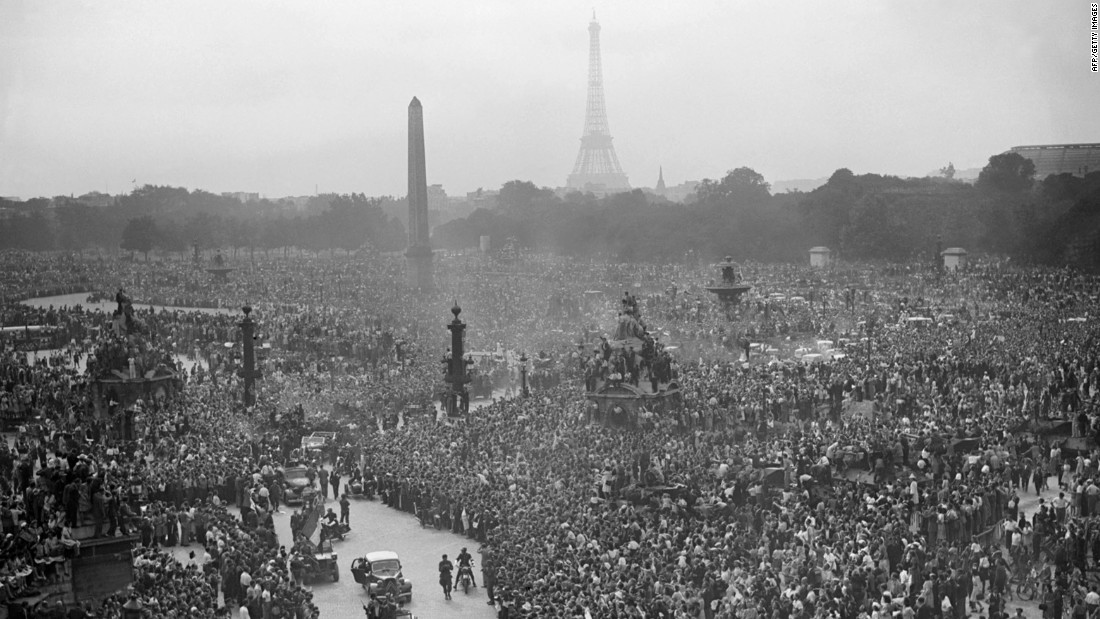Imagine you're standing in the crowd depicted in this photograph. What sights, sounds, and sensations do you experience? Standing amidst this immense crowd, you would be surrounded by the sights of waving flags, joyful faces, and historic Parisian landmarks like the Eiffel Tower in the distance. The air is filled with cheers, laughter, and perhaps the distant sound of national anthems or speeches being broadcasted. You might feel the warmth of bodies pressed closely, the exhilaration in the air, and the palpable sense of unity and patriotism. The scent of flowers and summer perhaps linger, mingling with the aroma of nearby street food vendors hurriedly serving the joyous masses. What kind of events throughout history might have drawn such large crowds to urban squares like the one in the image? Throughout history, urban squares have been sites for numerous significant gatherings. These include political demonstrations, celebrations of military victories, national holidays, public addresses by influential figures, and monumental historic events such as the end of wars or the signing of major treaties. For example, the liberation of cities from occupation, coronations, revolutions, or significant cultural festivals have all drawn enormous crowds to such public spaces to share in the collective experience of these profoundly impactful moments. What if the image depicted a fictional event — what wild, imaginative historical event could attract such a crowd? Imagine this image captures the grand celebration of humanity’s first contact with extraterrestrial beings in the heart of Paris. The sky would be abuzz with futuristic flying crafts, and the Eiffel Tower might be illuminated with otherworldly lights representing the peaceful union of civilizations. This unprecedented event draws citizens from all walks of life to witness the historic, universe-altering moment, making it a scene of extraordinary unity and global hope for a shared future amongst the stars.  Considering the scale and setting of the crowd, what would be a realistic reason for such a dense gathering in a major city today? In today's context, a dense gathering of this scale in a major city might be for several significant reasons. This could include celebrations of a major national sports victory, a massive political rally for a historic election, large public protests for social justice, or a national holiday commemorating an important event. For example, the final match of a major international football tournament or a major cultural festival could draw vast crowds to central urban locations.  What could the people in the photograph be feeling if this event were taking place in a time of national uncertainty or crisis? If this event were taking place in a time of national uncertainty or crisis, the crowd might be experiencing a mix of hope, solidarity, and possibly tension. They might gather to either support a cause, protest against an injustice, or simply find comfort in being united with their fellow citizens. The faces in the crowd would likely reflect a range of emotions from determination and resolve to anxiety and anticipation, creating a charged and poignant atmosphere that marks a critical moment in their national narrative. 